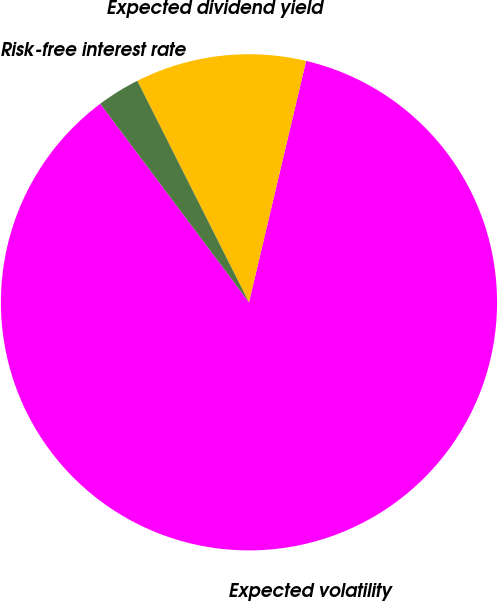Convert chart to OTSL. <chart><loc_0><loc_0><loc_500><loc_500><pie_chart><fcel>Expected volatility<fcel>Expected dividend yield<fcel>Risk-free interest rate<nl><fcel>86.07%<fcel>11.13%<fcel>2.8%<nl></chart> 